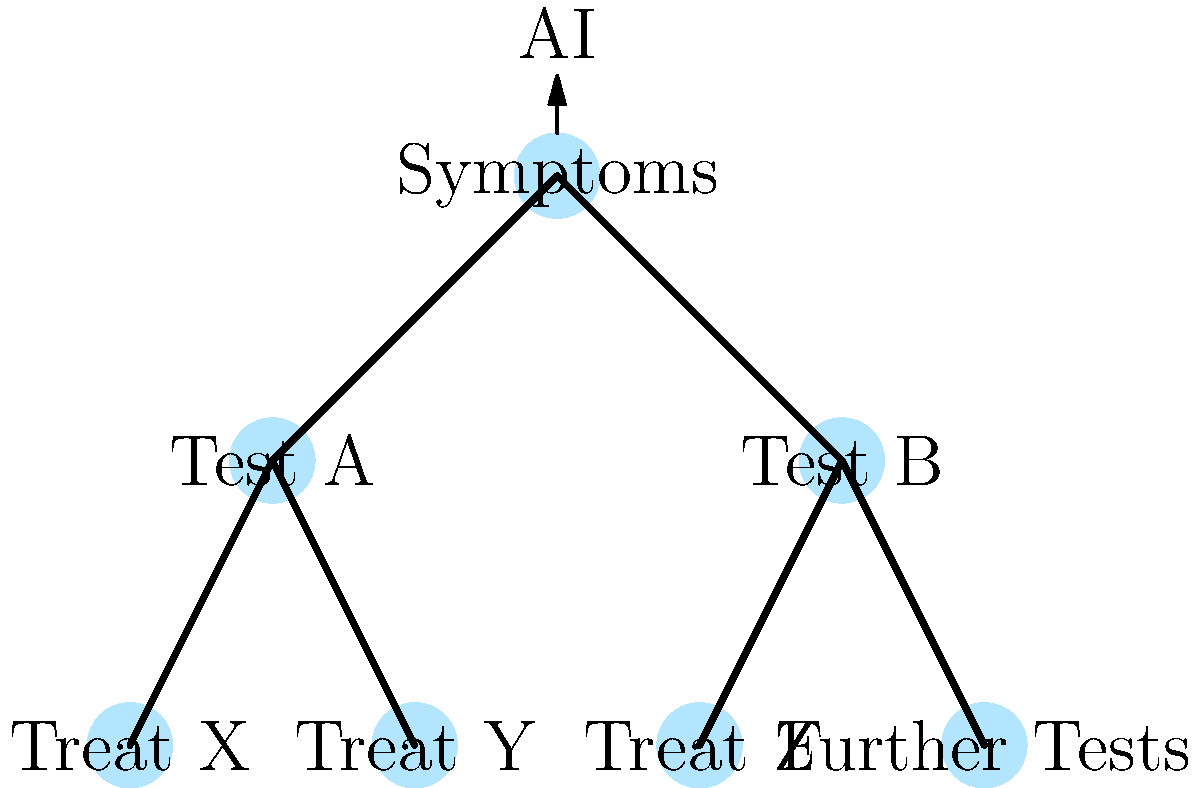In the context of AI-assisted diagnosis using decision trees, which ethical concern is most directly related to the potential for bias in the training data used to develop the AI system? To answer this question, let's consider the ethical implications of AI-assisted diagnosis using decision trees, step by step:

1. AI-assisted diagnosis: The diagram shows a decision tree where AI is used to guide the diagnostic process based on symptoms and test results.

2. Training data: AI systems, including those using decision trees, are trained on large datasets of patient information and outcomes.

3. Potential for bias: The ethical concern most directly related to training data is the potential for bias. This can occur in several ways:

   a. Underrepresentation: If certain demographic groups are underrepresented in the training data, the AI may not perform as well for these groups.
   
   b. Historical biases: If the training data reflects historical biases in healthcare (e.g., certain conditions being under-diagnosed in specific populations), these biases can be perpetuated by the AI.
   
   c. Data quality: If the quality of data varies across different groups, it can lead to disparities in diagnostic accuracy.

4. Impact on diagnosis: Biased training data can lead to:
   
   a. Misdiagnosis or delayed diagnosis for underrepresented groups.
   b. Perpetuation of healthcare disparities.
   c. Unequal access to appropriate treatments.

5. Ethical implications:
   
   a. Fairness and equality: Biased AI systems may violate principles of fairness in healthcare.
   b. Non-maleficence: Incorrect diagnoses due to bias could harm patients.
   c. Beneficence: The potential benefits of AI-assisted diagnosis may not be equally distributed.

6. Other ethical concerns:
   
   While there are other ethical concerns related to AI in healthcare (e.g., privacy, transparency, accountability), the question specifically asks about the concern most directly related to potential bias in training data.

Therefore, the ethical concern most directly related to the potential for bias in the training data is the risk of perpetuating or exacerbating healthcare disparities.
Answer: Perpetuation of healthcare disparities 